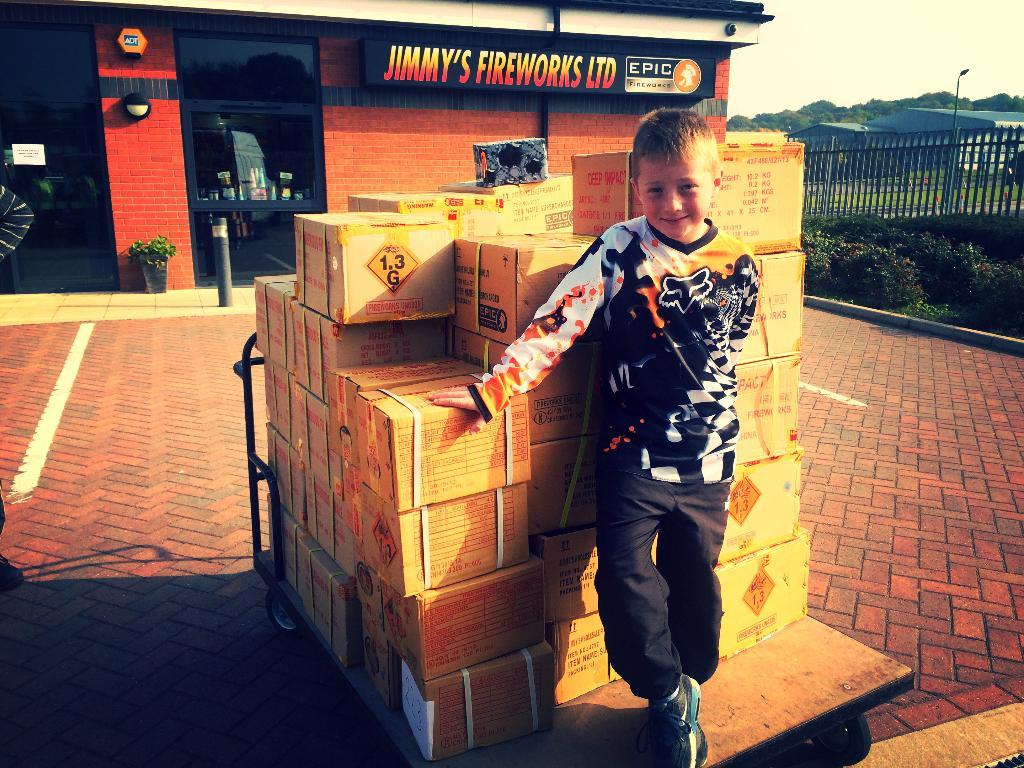<image>
Share a concise interpretation of the image provided. A child standing on a cart loaded with boxes in front of Jimmy's Fireworks LTD store. 